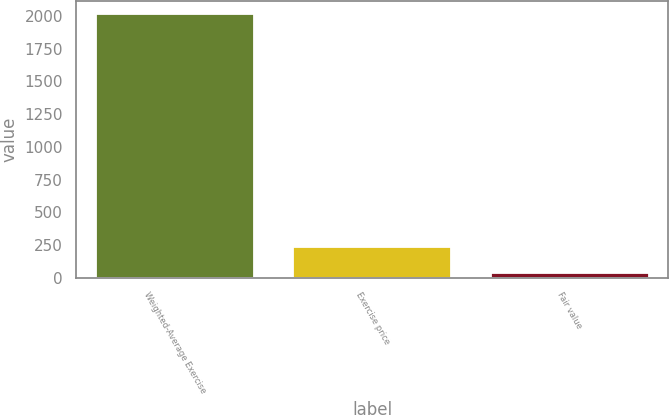<chart> <loc_0><loc_0><loc_500><loc_500><bar_chart><fcel>Weighted-Average Exercise<fcel>Exercise price<fcel>Fair value<nl><fcel>2015<fcel>233.76<fcel>35.84<nl></chart> 